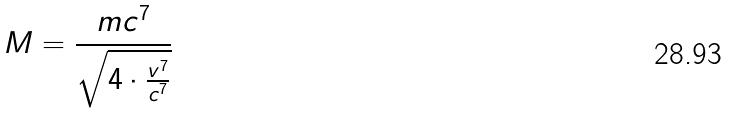Convert formula to latex. <formula><loc_0><loc_0><loc_500><loc_500>M = \frac { m c ^ { 7 } } { \sqrt { 4 \cdot \frac { v ^ { 7 } } { c ^ { 7 } } } }</formula> 